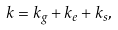Convert formula to latex. <formula><loc_0><loc_0><loc_500><loc_500>k = k _ { g } + k _ { e } + k _ { s } ,</formula> 